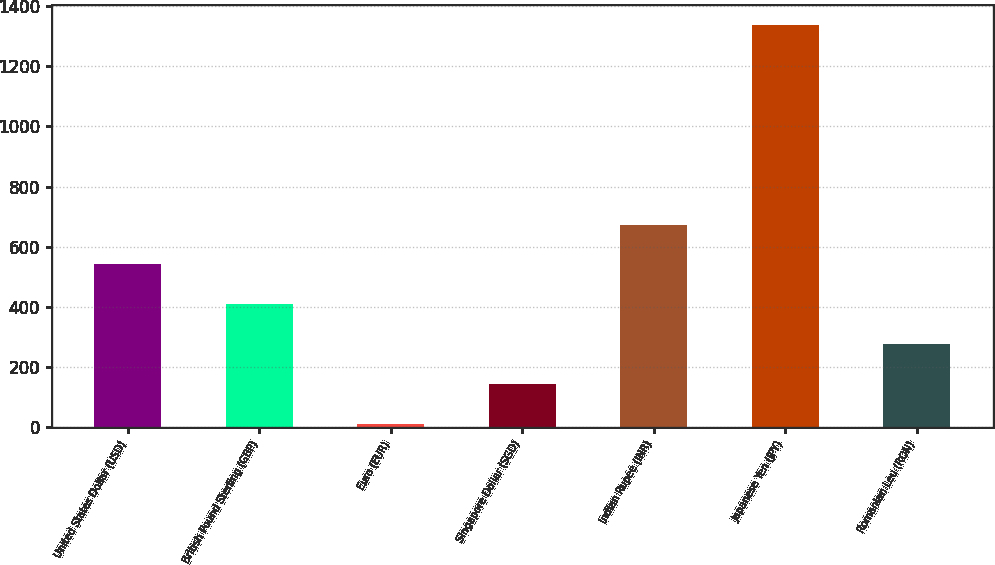<chart> <loc_0><loc_0><loc_500><loc_500><bar_chart><fcel>United States Dollar (USD)<fcel>British Pound Sterling (GBP)<fcel>Euro (EUR)<fcel>Singapore Dollar (SGD)<fcel>Indian Rupee (INR)<fcel>Japanese Yen (JPY)<fcel>Romanian Leu (RON)<nl><fcel>541.2<fcel>408.9<fcel>12<fcel>144.3<fcel>673.5<fcel>1335<fcel>276.6<nl></chart> 